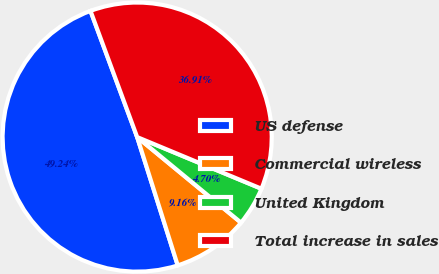Convert chart. <chart><loc_0><loc_0><loc_500><loc_500><pie_chart><fcel>US defense<fcel>Commercial wireless<fcel>United Kingdom<fcel>Total increase in sales<nl><fcel>49.24%<fcel>9.16%<fcel>4.7%<fcel>36.91%<nl></chart> 